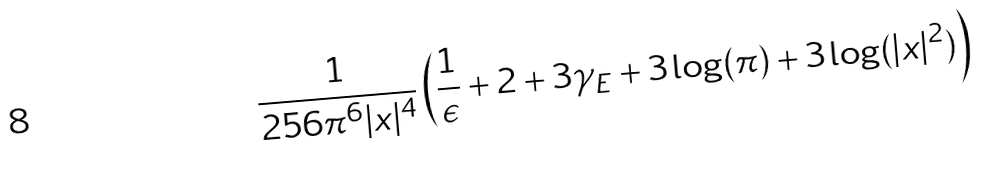Convert formula to latex. <formula><loc_0><loc_0><loc_500><loc_500>\frac { 1 } { 2 5 6 \pi ^ { 6 } | x | ^ { 4 } } \left ( \frac { 1 } { \epsilon } + 2 + 3 \gamma _ { E } + 3 \log ( \pi ) + 3 \log ( | x | ^ { 2 } ) \right )</formula> 